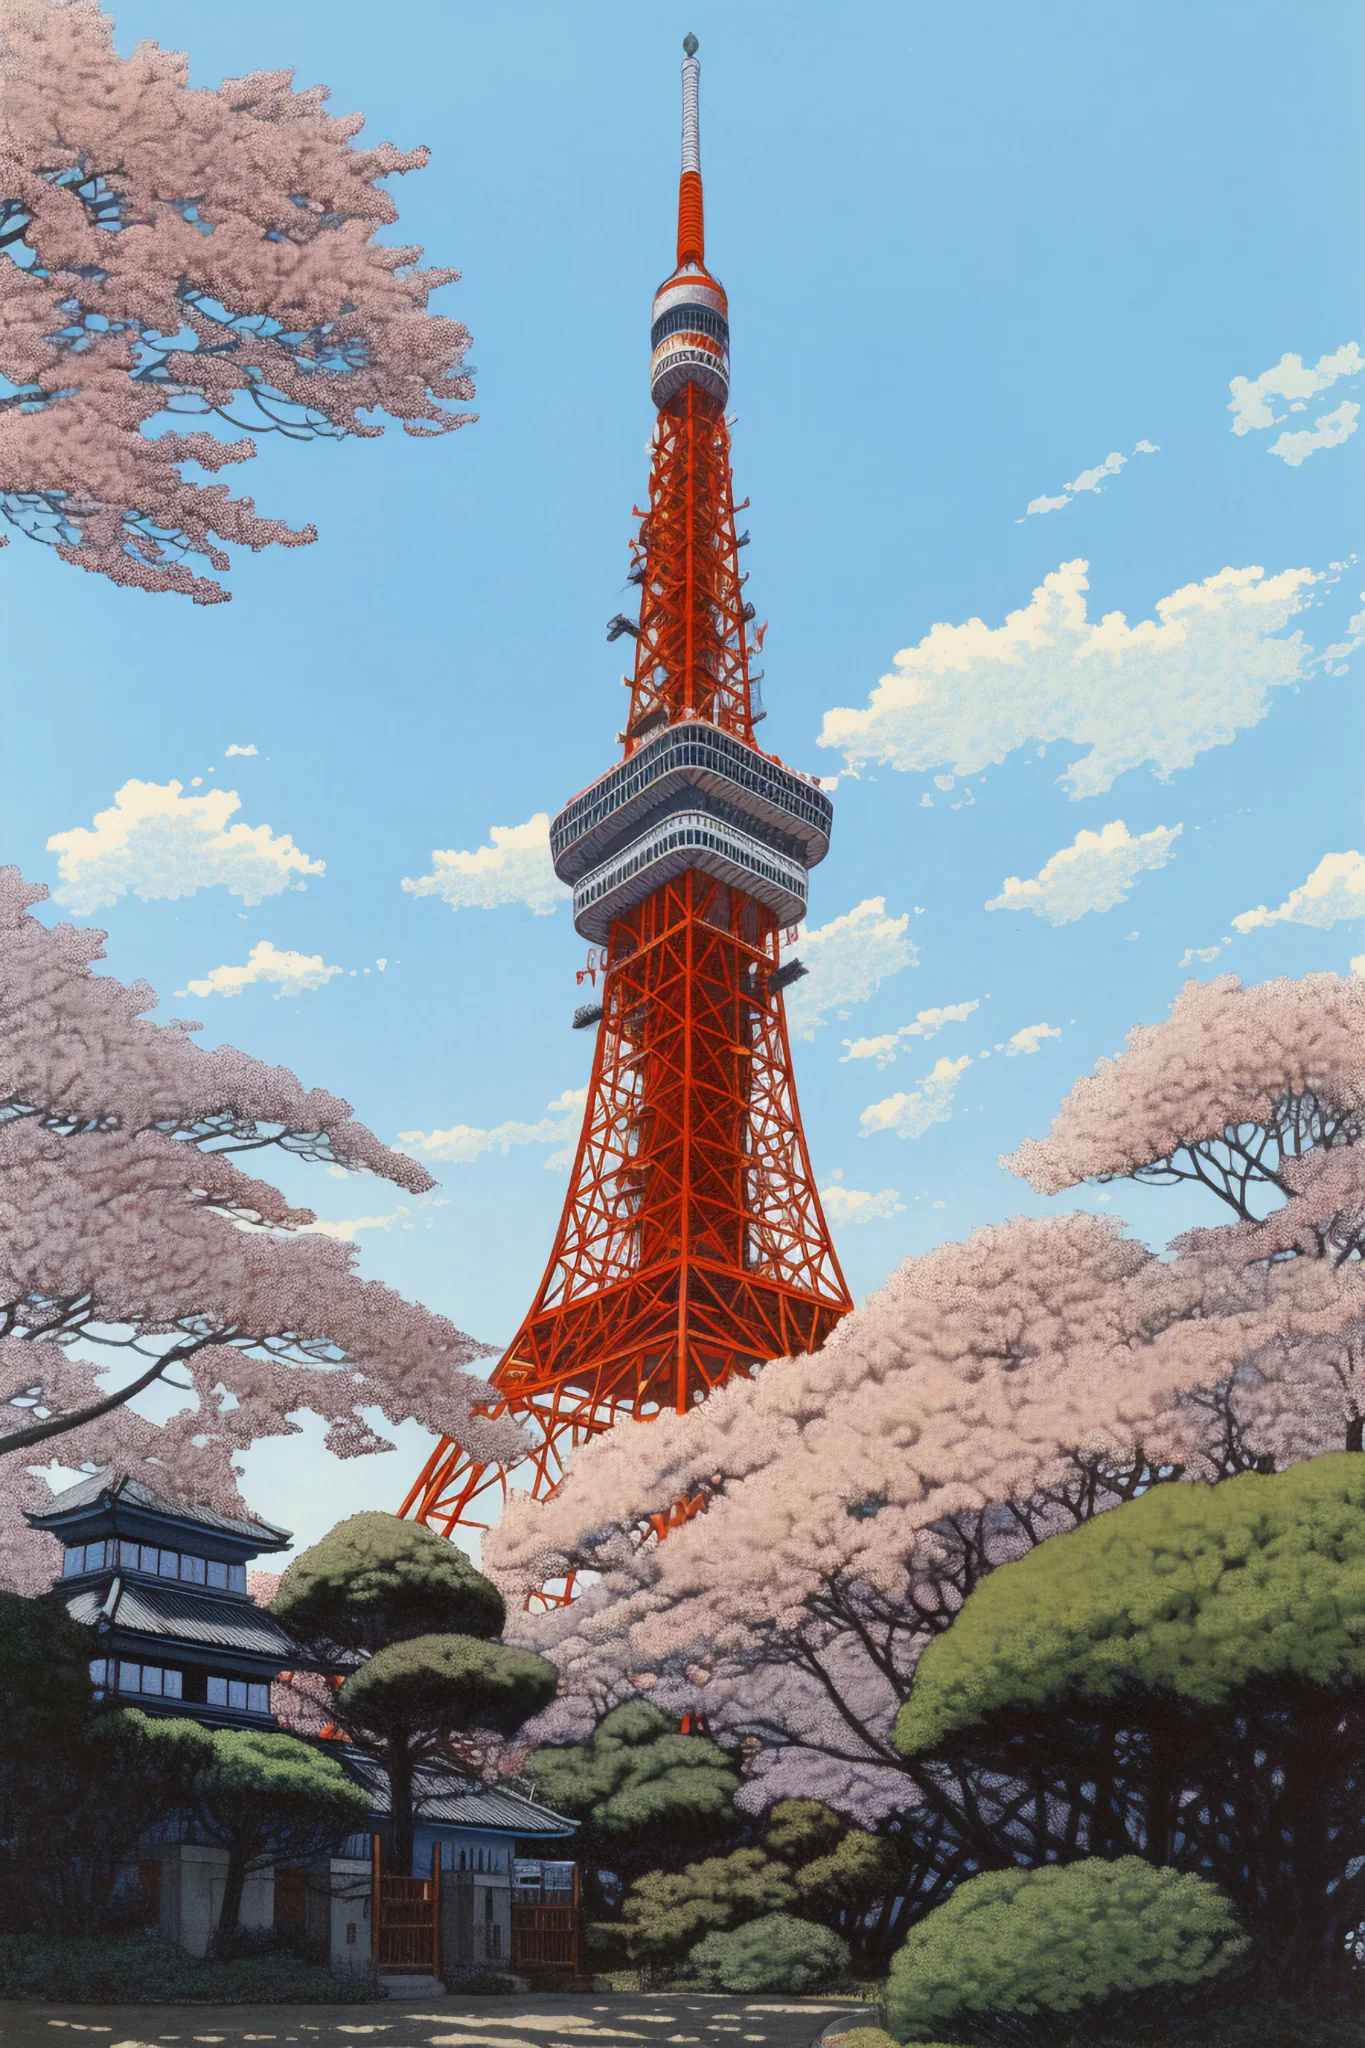Can you craft a haiku inspired by this scene? Blossoms kiss the sky,
Orange tower pierces blue,
Spring whispers softly. 